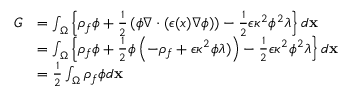<formula> <loc_0><loc_0><loc_500><loc_500>\begin{array} { r l } { G } & { = \int _ { \Omega } \left \{ \rho _ { f } \phi + \frac { 1 } { 2 } \left ( \phi \nabla \cdot ( \epsilon ( x ) \nabla \phi ) \right ) - \frac { 1 } { 2 } \epsilon \kappa ^ { 2 } \phi ^ { 2 } \lambda \right \} d x } \\ & { = \int _ { \Omega } \left \{ \rho _ { f } \phi + \frac { 1 } { 2 } \phi \left ( - \rho _ { f } + \epsilon \kappa ^ { 2 } \phi \lambda ) \right ) - \frac { 1 } { 2 } \epsilon \kappa ^ { 2 } \phi ^ { 2 } \lambda \right \} d x } \\ & { = \frac { 1 } { 2 } \int _ { \Omega } \rho _ { f } \phi d x } \end{array}</formula> 